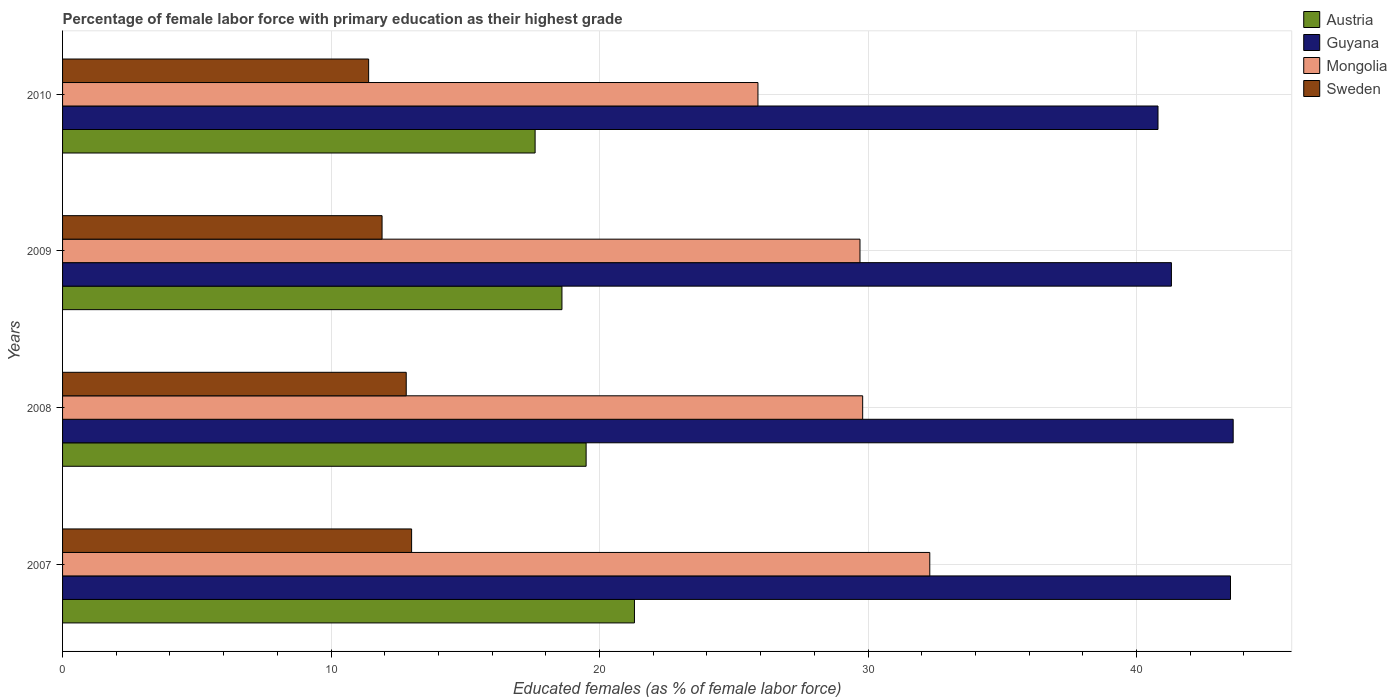How many different coloured bars are there?
Make the answer very short. 4. How many groups of bars are there?
Your answer should be compact. 4. Are the number of bars per tick equal to the number of legend labels?
Ensure brevity in your answer.  Yes. Are the number of bars on each tick of the Y-axis equal?
Make the answer very short. Yes. How many bars are there on the 3rd tick from the top?
Your answer should be very brief. 4. How many bars are there on the 3rd tick from the bottom?
Ensure brevity in your answer.  4. What is the percentage of female labor force with primary education in Sweden in 2010?
Offer a terse response. 11.4. Across all years, what is the maximum percentage of female labor force with primary education in Sweden?
Your response must be concise. 13. Across all years, what is the minimum percentage of female labor force with primary education in Mongolia?
Your answer should be very brief. 25.9. What is the total percentage of female labor force with primary education in Austria in the graph?
Your response must be concise. 77. What is the difference between the percentage of female labor force with primary education in Guyana in 2007 and that in 2010?
Ensure brevity in your answer.  2.7. What is the difference between the percentage of female labor force with primary education in Mongolia in 2010 and the percentage of female labor force with primary education in Guyana in 2008?
Make the answer very short. -17.7. What is the average percentage of female labor force with primary education in Sweden per year?
Give a very brief answer. 12.27. In the year 2008, what is the difference between the percentage of female labor force with primary education in Mongolia and percentage of female labor force with primary education in Austria?
Offer a very short reply. 10.3. In how many years, is the percentage of female labor force with primary education in Sweden greater than 36 %?
Keep it short and to the point. 0. What is the ratio of the percentage of female labor force with primary education in Sweden in 2008 to that in 2009?
Offer a terse response. 1.08. What is the difference between the highest and the second highest percentage of female labor force with primary education in Guyana?
Provide a succinct answer. 0.1. What is the difference between the highest and the lowest percentage of female labor force with primary education in Guyana?
Make the answer very short. 2.8. Is the sum of the percentage of female labor force with primary education in Mongolia in 2008 and 2010 greater than the maximum percentage of female labor force with primary education in Sweden across all years?
Your answer should be very brief. Yes. Is it the case that in every year, the sum of the percentage of female labor force with primary education in Guyana and percentage of female labor force with primary education in Sweden is greater than the sum of percentage of female labor force with primary education in Mongolia and percentage of female labor force with primary education in Austria?
Make the answer very short. Yes. What does the 3rd bar from the top in 2009 represents?
Offer a very short reply. Guyana. What does the 2nd bar from the bottom in 2008 represents?
Your answer should be compact. Guyana. Is it the case that in every year, the sum of the percentage of female labor force with primary education in Mongolia and percentage of female labor force with primary education in Sweden is greater than the percentage of female labor force with primary education in Austria?
Make the answer very short. Yes. Does the graph contain any zero values?
Your answer should be compact. No. How many legend labels are there?
Ensure brevity in your answer.  4. How are the legend labels stacked?
Provide a short and direct response. Vertical. What is the title of the graph?
Offer a very short reply. Percentage of female labor force with primary education as their highest grade. What is the label or title of the X-axis?
Your answer should be very brief. Educated females (as % of female labor force). What is the label or title of the Y-axis?
Give a very brief answer. Years. What is the Educated females (as % of female labor force) of Austria in 2007?
Your response must be concise. 21.3. What is the Educated females (as % of female labor force) in Guyana in 2007?
Keep it short and to the point. 43.5. What is the Educated females (as % of female labor force) of Mongolia in 2007?
Your answer should be compact. 32.3. What is the Educated females (as % of female labor force) of Sweden in 2007?
Offer a terse response. 13. What is the Educated females (as % of female labor force) of Austria in 2008?
Your answer should be compact. 19.5. What is the Educated females (as % of female labor force) in Guyana in 2008?
Ensure brevity in your answer.  43.6. What is the Educated females (as % of female labor force) in Mongolia in 2008?
Make the answer very short. 29.8. What is the Educated females (as % of female labor force) of Sweden in 2008?
Keep it short and to the point. 12.8. What is the Educated females (as % of female labor force) of Austria in 2009?
Your response must be concise. 18.6. What is the Educated females (as % of female labor force) in Guyana in 2009?
Offer a terse response. 41.3. What is the Educated females (as % of female labor force) in Mongolia in 2009?
Ensure brevity in your answer.  29.7. What is the Educated females (as % of female labor force) of Sweden in 2009?
Ensure brevity in your answer.  11.9. What is the Educated females (as % of female labor force) in Austria in 2010?
Keep it short and to the point. 17.6. What is the Educated females (as % of female labor force) of Guyana in 2010?
Your response must be concise. 40.8. What is the Educated females (as % of female labor force) in Mongolia in 2010?
Make the answer very short. 25.9. What is the Educated females (as % of female labor force) of Sweden in 2010?
Make the answer very short. 11.4. Across all years, what is the maximum Educated females (as % of female labor force) of Austria?
Provide a succinct answer. 21.3. Across all years, what is the maximum Educated females (as % of female labor force) in Guyana?
Your answer should be compact. 43.6. Across all years, what is the maximum Educated females (as % of female labor force) in Mongolia?
Your response must be concise. 32.3. Across all years, what is the minimum Educated females (as % of female labor force) of Austria?
Keep it short and to the point. 17.6. Across all years, what is the minimum Educated females (as % of female labor force) in Guyana?
Your answer should be compact. 40.8. Across all years, what is the minimum Educated females (as % of female labor force) of Mongolia?
Your answer should be very brief. 25.9. Across all years, what is the minimum Educated females (as % of female labor force) in Sweden?
Offer a very short reply. 11.4. What is the total Educated females (as % of female labor force) of Austria in the graph?
Offer a terse response. 77. What is the total Educated females (as % of female labor force) in Guyana in the graph?
Your answer should be compact. 169.2. What is the total Educated females (as % of female labor force) in Mongolia in the graph?
Keep it short and to the point. 117.7. What is the total Educated females (as % of female labor force) of Sweden in the graph?
Your answer should be very brief. 49.1. What is the difference between the Educated females (as % of female labor force) in Guyana in 2007 and that in 2008?
Offer a very short reply. -0.1. What is the difference between the Educated females (as % of female labor force) of Austria in 2007 and that in 2009?
Ensure brevity in your answer.  2.7. What is the difference between the Educated females (as % of female labor force) in Sweden in 2007 and that in 2009?
Your answer should be very brief. 1.1. What is the difference between the Educated females (as % of female labor force) of Austria in 2007 and that in 2010?
Offer a terse response. 3.7. What is the difference between the Educated females (as % of female labor force) of Mongolia in 2007 and that in 2010?
Ensure brevity in your answer.  6.4. What is the difference between the Educated females (as % of female labor force) in Guyana in 2008 and that in 2009?
Your answer should be compact. 2.3. What is the difference between the Educated females (as % of female labor force) of Sweden in 2008 and that in 2009?
Provide a succinct answer. 0.9. What is the difference between the Educated females (as % of female labor force) in Guyana in 2008 and that in 2010?
Keep it short and to the point. 2.8. What is the difference between the Educated females (as % of female labor force) in Sweden in 2008 and that in 2010?
Offer a terse response. 1.4. What is the difference between the Educated females (as % of female labor force) of Austria in 2009 and that in 2010?
Ensure brevity in your answer.  1. What is the difference between the Educated females (as % of female labor force) in Guyana in 2009 and that in 2010?
Keep it short and to the point. 0.5. What is the difference between the Educated females (as % of female labor force) of Mongolia in 2009 and that in 2010?
Provide a short and direct response. 3.8. What is the difference between the Educated females (as % of female labor force) in Austria in 2007 and the Educated females (as % of female labor force) in Guyana in 2008?
Make the answer very short. -22.3. What is the difference between the Educated females (as % of female labor force) of Austria in 2007 and the Educated females (as % of female labor force) of Mongolia in 2008?
Provide a short and direct response. -8.5. What is the difference between the Educated females (as % of female labor force) in Guyana in 2007 and the Educated females (as % of female labor force) in Mongolia in 2008?
Ensure brevity in your answer.  13.7. What is the difference between the Educated females (as % of female labor force) in Guyana in 2007 and the Educated females (as % of female labor force) in Sweden in 2008?
Provide a short and direct response. 30.7. What is the difference between the Educated females (as % of female labor force) in Mongolia in 2007 and the Educated females (as % of female labor force) in Sweden in 2008?
Offer a terse response. 19.5. What is the difference between the Educated females (as % of female labor force) of Austria in 2007 and the Educated females (as % of female labor force) of Mongolia in 2009?
Provide a succinct answer. -8.4. What is the difference between the Educated females (as % of female labor force) of Guyana in 2007 and the Educated females (as % of female labor force) of Mongolia in 2009?
Make the answer very short. 13.8. What is the difference between the Educated females (as % of female labor force) of Guyana in 2007 and the Educated females (as % of female labor force) of Sweden in 2009?
Offer a terse response. 31.6. What is the difference between the Educated females (as % of female labor force) of Mongolia in 2007 and the Educated females (as % of female labor force) of Sweden in 2009?
Your answer should be very brief. 20.4. What is the difference between the Educated females (as % of female labor force) in Austria in 2007 and the Educated females (as % of female labor force) in Guyana in 2010?
Offer a terse response. -19.5. What is the difference between the Educated females (as % of female labor force) in Guyana in 2007 and the Educated females (as % of female labor force) in Mongolia in 2010?
Your response must be concise. 17.6. What is the difference between the Educated females (as % of female labor force) of Guyana in 2007 and the Educated females (as % of female labor force) of Sweden in 2010?
Provide a succinct answer. 32.1. What is the difference between the Educated females (as % of female labor force) of Mongolia in 2007 and the Educated females (as % of female labor force) of Sweden in 2010?
Provide a short and direct response. 20.9. What is the difference between the Educated females (as % of female labor force) in Austria in 2008 and the Educated females (as % of female labor force) in Guyana in 2009?
Make the answer very short. -21.8. What is the difference between the Educated females (as % of female labor force) in Austria in 2008 and the Educated females (as % of female labor force) in Mongolia in 2009?
Your response must be concise. -10.2. What is the difference between the Educated females (as % of female labor force) of Austria in 2008 and the Educated females (as % of female labor force) of Sweden in 2009?
Provide a short and direct response. 7.6. What is the difference between the Educated females (as % of female labor force) in Guyana in 2008 and the Educated females (as % of female labor force) in Sweden in 2009?
Your answer should be compact. 31.7. What is the difference between the Educated females (as % of female labor force) of Austria in 2008 and the Educated females (as % of female labor force) of Guyana in 2010?
Offer a terse response. -21.3. What is the difference between the Educated females (as % of female labor force) in Austria in 2008 and the Educated females (as % of female labor force) in Mongolia in 2010?
Make the answer very short. -6.4. What is the difference between the Educated females (as % of female labor force) of Austria in 2008 and the Educated females (as % of female labor force) of Sweden in 2010?
Make the answer very short. 8.1. What is the difference between the Educated females (as % of female labor force) of Guyana in 2008 and the Educated females (as % of female labor force) of Mongolia in 2010?
Provide a short and direct response. 17.7. What is the difference between the Educated females (as % of female labor force) in Guyana in 2008 and the Educated females (as % of female labor force) in Sweden in 2010?
Provide a short and direct response. 32.2. What is the difference between the Educated females (as % of female labor force) of Mongolia in 2008 and the Educated females (as % of female labor force) of Sweden in 2010?
Keep it short and to the point. 18.4. What is the difference between the Educated females (as % of female labor force) in Austria in 2009 and the Educated females (as % of female labor force) in Guyana in 2010?
Provide a short and direct response. -22.2. What is the difference between the Educated females (as % of female labor force) of Austria in 2009 and the Educated females (as % of female labor force) of Mongolia in 2010?
Your answer should be compact. -7.3. What is the difference between the Educated females (as % of female labor force) of Austria in 2009 and the Educated females (as % of female labor force) of Sweden in 2010?
Keep it short and to the point. 7.2. What is the difference between the Educated females (as % of female labor force) of Guyana in 2009 and the Educated females (as % of female labor force) of Sweden in 2010?
Your answer should be very brief. 29.9. What is the average Educated females (as % of female labor force) in Austria per year?
Offer a very short reply. 19.25. What is the average Educated females (as % of female labor force) in Guyana per year?
Offer a terse response. 42.3. What is the average Educated females (as % of female labor force) of Mongolia per year?
Provide a succinct answer. 29.43. What is the average Educated females (as % of female labor force) in Sweden per year?
Provide a succinct answer. 12.28. In the year 2007, what is the difference between the Educated females (as % of female labor force) in Austria and Educated females (as % of female labor force) in Guyana?
Your answer should be very brief. -22.2. In the year 2007, what is the difference between the Educated females (as % of female labor force) in Austria and Educated females (as % of female labor force) in Mongolia?
Offer a very short reply. -11. In the year 2007, what is the difference between the Educated females (as % of female labor force) of Guyana and Educated females (as % of female labor force) of Sweden?
Make the answer very short. 30.5. In the year 2007, what is the difference between the Educated females (as % of female labor force) in Mongolia and Educated females (as % of female labor force) in Sweden?
Your answer should be compact. 19.3. In the year 2008, what is the difference between the Educated females (as % of female labor force) in Austria and Educated females (as % of female labor force) in Guyana?
Give a very brief answer. -24.1. In the year 2008, what is the difference between the Educated females (as % of female labor force) in Austria and Educated females (as % of female labor force) in Sweden?
Ensure brevity in your answer.  6.7. In the year 2008, what is the difference between the Educated females (as % of female labor force) in Guyana and Educated females (as % of female labor force) in Mongolia?
Give a very brief answer. 13.8. In the year 2008, what is the difference between the Educated females (as % of female labor force) of Guyana and Educated females (as % of female labor force) of Sweden?
Your answer should be compact. 30.8. In the year 2008, what is the difference between the Educated females (as % of female labor force) of Mongolia and Educated females (as % of female labor force) of Sweden?
Make the answer very short. 17. In the year 2009, what is the difference between the Educated females (as % of female labor force) in Austria and Educated females (as % of female labor force) in Guyana?
Your answer should be very brief. -22.7. In the year 2009, what is the difference between the Educated females (as % of female labor force) of Guyana and Educated females (as % of female labor force) of Mongolia?
Make the answer very short. 11.6. In the year 2009, what is the difference between the Educated females (as % of female labor force) of Guyana and Educated females (as % of female labor force) of Sweden?
Your answer should be very brief. 29.4. In the year 2009, what is the difference between the Educated females (as % of female labor force) in Mongolia and Educated females (as % of female labor force) in Sweden?
Give a very brief answer. 17.8. In the year 2010, what is the difference between the Educated females (as % of female labor force) in Austria and Educated females (as % of female labor force) in Guyana?
Provide a succinct answer. -23.2. In the year 2010, what is the difference between the Educated females (as % of female labor force) of Austria and Educated females (as % of female labor force) of Mongolia?
Make the answer very short. -8.3. In the year 2010, what is the difference between the Educated females (as % of female labor force) of Austria and Educated females (as % of female labor force) of Sweden?
Give a very brief answer. 6.2. In the year 2010, what is the difference between the Educated females (as % of female labor force) of Guyana and Educated females (as % of female labor force) of Mongolia?
Provide a succinct answer. 14.9. In the year 2010, what is the difference between the Educated females (as % of female labor force) in Guyana and Educated females (as % of female labor force) in Sweden?
Offer a terse response. 29.4. In the year 2010, what is the difference between the Educated females (as % of female labor force) in Mongolia and Educated females (as % of female labor force) in Sweden?
Provide a succinct answer. 14.5. What is the ratio of the Educated females (as % of female labor force) of Austria in 2007 to that in 2008?
Ensure brevity in your answer.  1.09. What is the ratio of the Educated females (as % of female labor force) of Mongolia in 2007 to that in 2008?
Your answer should be very brief. 1.08. What is the ratio of the Educated females (as % of female labor force) of Sweden in 2007 to that in 2008?
Your response must be concise. 1.02. What is the ratio of the Educated females (as % of female labor force) in Austria in 2007 to that in 2009?
Your response must be concise. 1.15. What is the ratio of the Educated females (as % of female labor force) of Guyana in 2007 to that in 2009?
Provide a succinct answer. 1.05. What is the ratio of the Educated females (as % of female labor force) of Mongolia in 2007 to that in 2009?
Provide a succinct answer. 1.09. What is the ratio of the Educated females (as % of female labor force) of Sweden in 2007 to that in 2009?
Your response must be concise. 1.09. What is the ratio of the Educated females (as % of female labor force) in Austria in 2007 to that in 2010?
Provide a succinct answer. 1.21. What is the ratio of the Educated females (as % of female labor force) in Guyana in 2007 to that in 2010?
Give a very brief answer. 1.07. What is the ratio of the Educated females (as % of female labor force) in Mongolia in 2007 to that in 2010?
Your answer should be compact. 1.25. What is the ratio of the Educated females (as % of female labor force) in Sweden in 2007 to that in 2010?
Offer a very short reply. 1.14. What is the ratio of the Educated females (as % of female labor force) of Austria in 2008 to that in 2009?
Offer a very short reply. 1.05. What is the ratio of the Educated females (as % of female labor force) of Guyana in 2008 to that in 2009?
Your answer should be very brief. 1.06. What is the ratio of the Educated females (as % of female labor force) of Mongolia in 2008 to that in 2009?
Make the answer very short. 1. What is the ratio of the Educated females (as % of female labor force) in Sweden in 2008 to that in 2009?
Your answer should be compact. 1.08. What is the ratio of the Educated females (as % of female labor force) in Austria in 2008 to that in 2010?
Your response must be concise. 1.11. What is the ratio of the Educated females (as % of female labor force) of Guyana in 2008 to that in 2010?
Provide a succinct answer. 1.07. What is the ratio of the Educated females (as % of female labor force) of Mongolia in 2008 to that in 2010?
Your response must be concise. 1.15. What is the ratio of the Educated females (as % of female labor force) of Sweden in 2008 to that in 2010?
Ensure brevity in your answer.  1.12. What is the ratio of the Educated females (as % of female labor force) in Austria in 2009 to that in 2010?
Your answer should be compact. 1.06. What is the ratio of the Educated females (as % of female labor force) in Guyana in 2009 to that in 2010?
Give a very brief answer. 1.01. What is the ratio of the Educated females (as % of female labor force) in Mongolia in 2009 to that in 2010?
Your answer should be compact. 1.15. What is the ratio of the Educated females (as % of female labor force) in Sweden in 2009 to that in 2010?
Provide a succinct answer. 1.04. What is the difference between the highest and the second highest Educated females (as % of female labor force) of Mongolia?
Offer a terse response. 2.5. What is the difference between the highest and the second highest Educated females (as % of female labor force) in Sweden?
Your response must be concise. 0.2. What is the difference between the highest and the lowest Educated females (as % of female labor force) in Austria?
Your answer should be compact. 3.7. What is the difference between the highest and the lowest Educated females (as % of female labor force) in Guyana?
Your answer should be very brief. 2.8. 